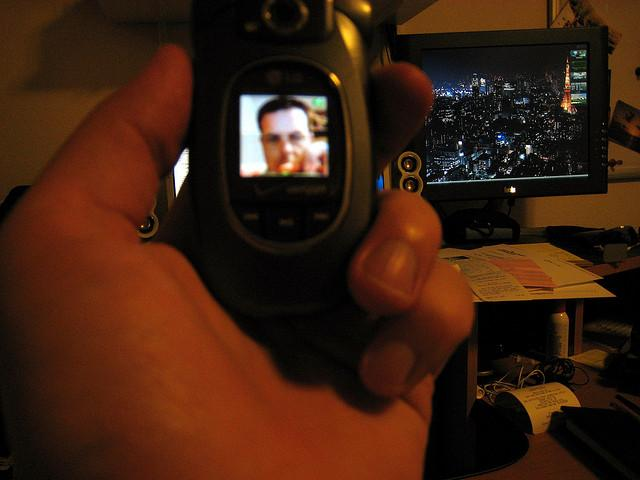What type of telephone does this person have? Please explain your reasoning. cellular. It is a small flip phone. 